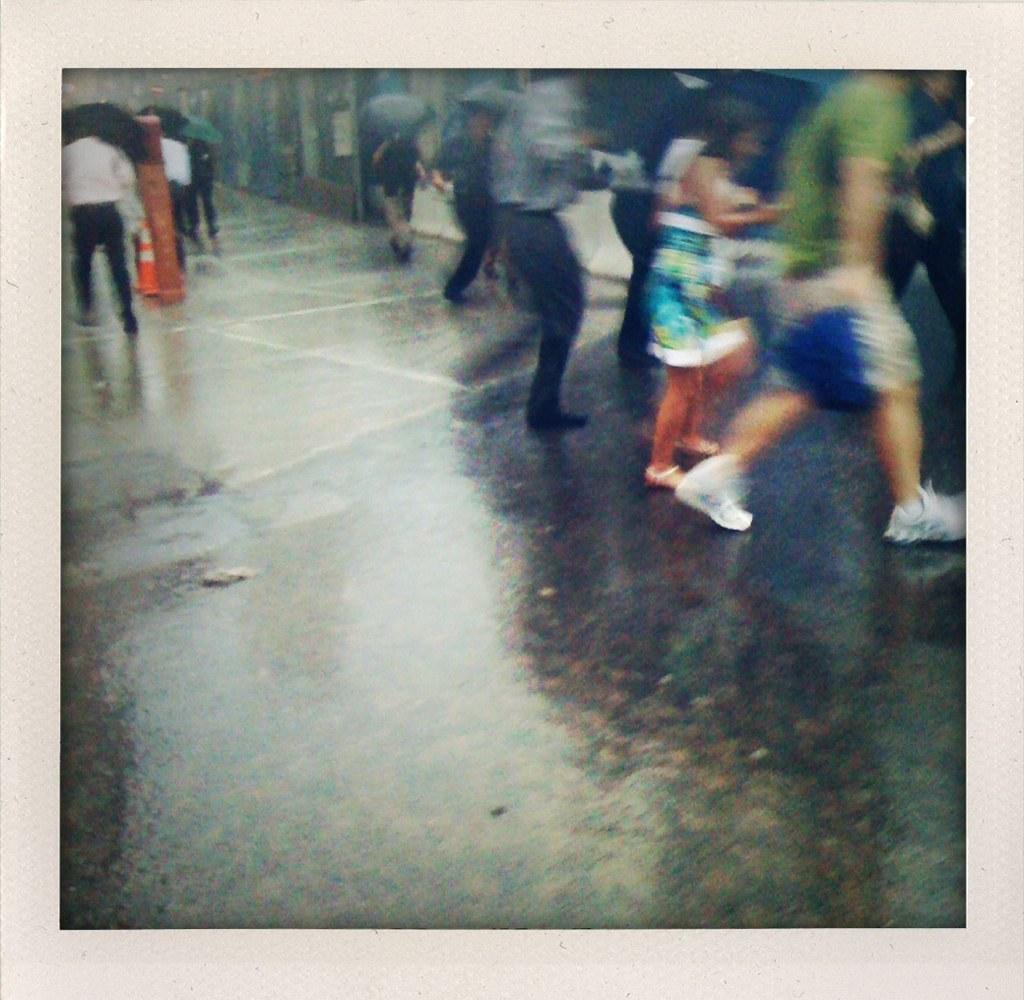Can you describe this image briefly? In this image, we can see people on the road and are holding umbrellas and we can see a pole and a traffic cone. In the background, there is a wall. 